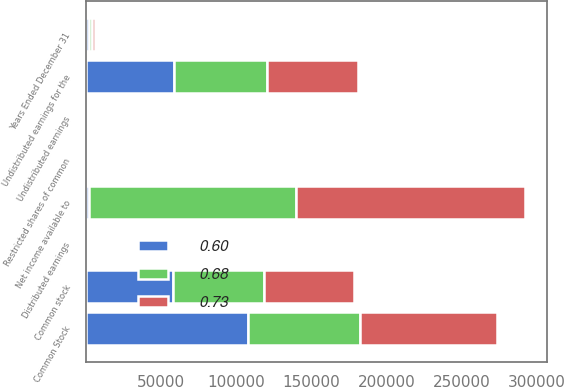<chart> <loc_0><loc_0><loc_500><loc_500><stacked_bar_chart><ecel><fcel>Years Ended December 31<fcel>Net income available to<fcel>Common Stock<fcel>Restricted shares of common<fcel>Undistributed earnings for the<fcel>Common stock<fcel>Distributed earnings<fcel>Undistributed earnings<nl><fcel>0.6<fcel>2016<fcel>2016<fcel>107880<fcel>1122<fcel>58367<fcel>57722<fcel>0.5<fcel>0.27<nl><fcel>0.73<fcel>2015<fcel>152149<fcel>90631<fcel>1124<fcel>60394<fcel>59611<fcel>0.42<fcel>0.28<nl><fcel>0.68<fcel>2014<fcel>137664<fcel>74704<fcel>1046<fcel>61914<fcel>61001<fcel>0.35<fcel>0.28<nl></chart> 